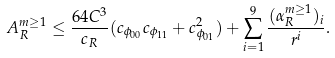Convert formula to latex. <formula><loc_0><loc_0><loc_500><loc_500>A ^ { m \geq 1 } _ { R } \leq \frac { 6 4 C ^ { 3 } } { c _ { R } } ( c _ { \phi _ { 0 0 } } c _ { \phi _ { 1 1 } } + c _ { \phi _ { 0 1 } } ^ { 2 } ) + \sum _ { i = 1 } ^ { 9 } \frac { ( \alpha _ { R } ^ { m \geq 1 } ) _ { i } } { r ^ { i } } .</formula> 